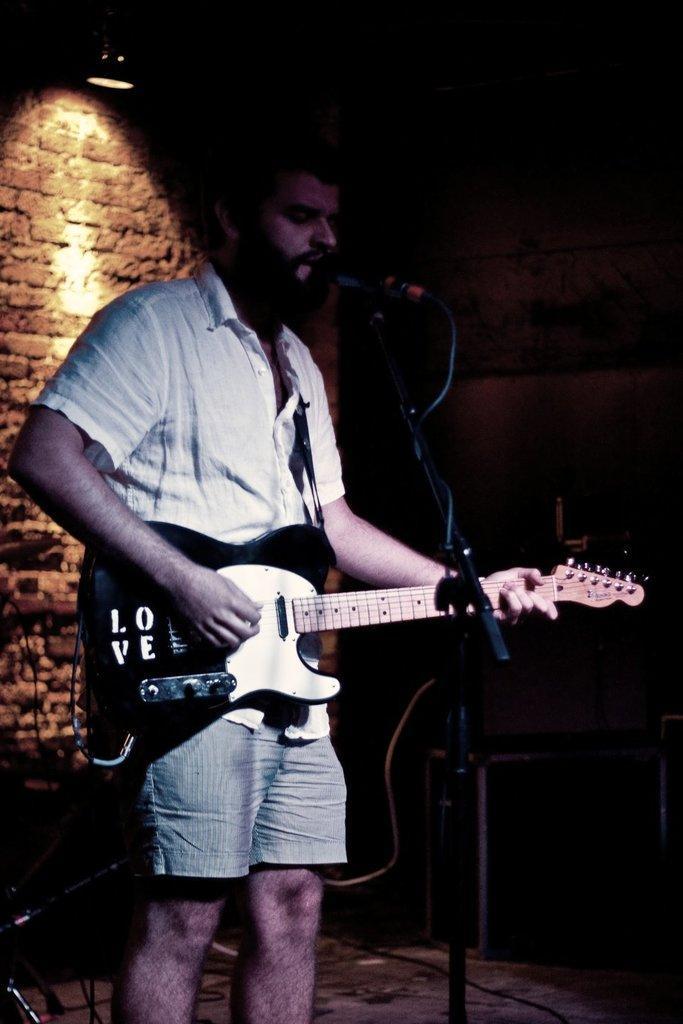How would you summarize this image in a sentence or two? in this image the person is playing the guitar in front of mike and behind the person some instruments are there in the back ground is very dark. 